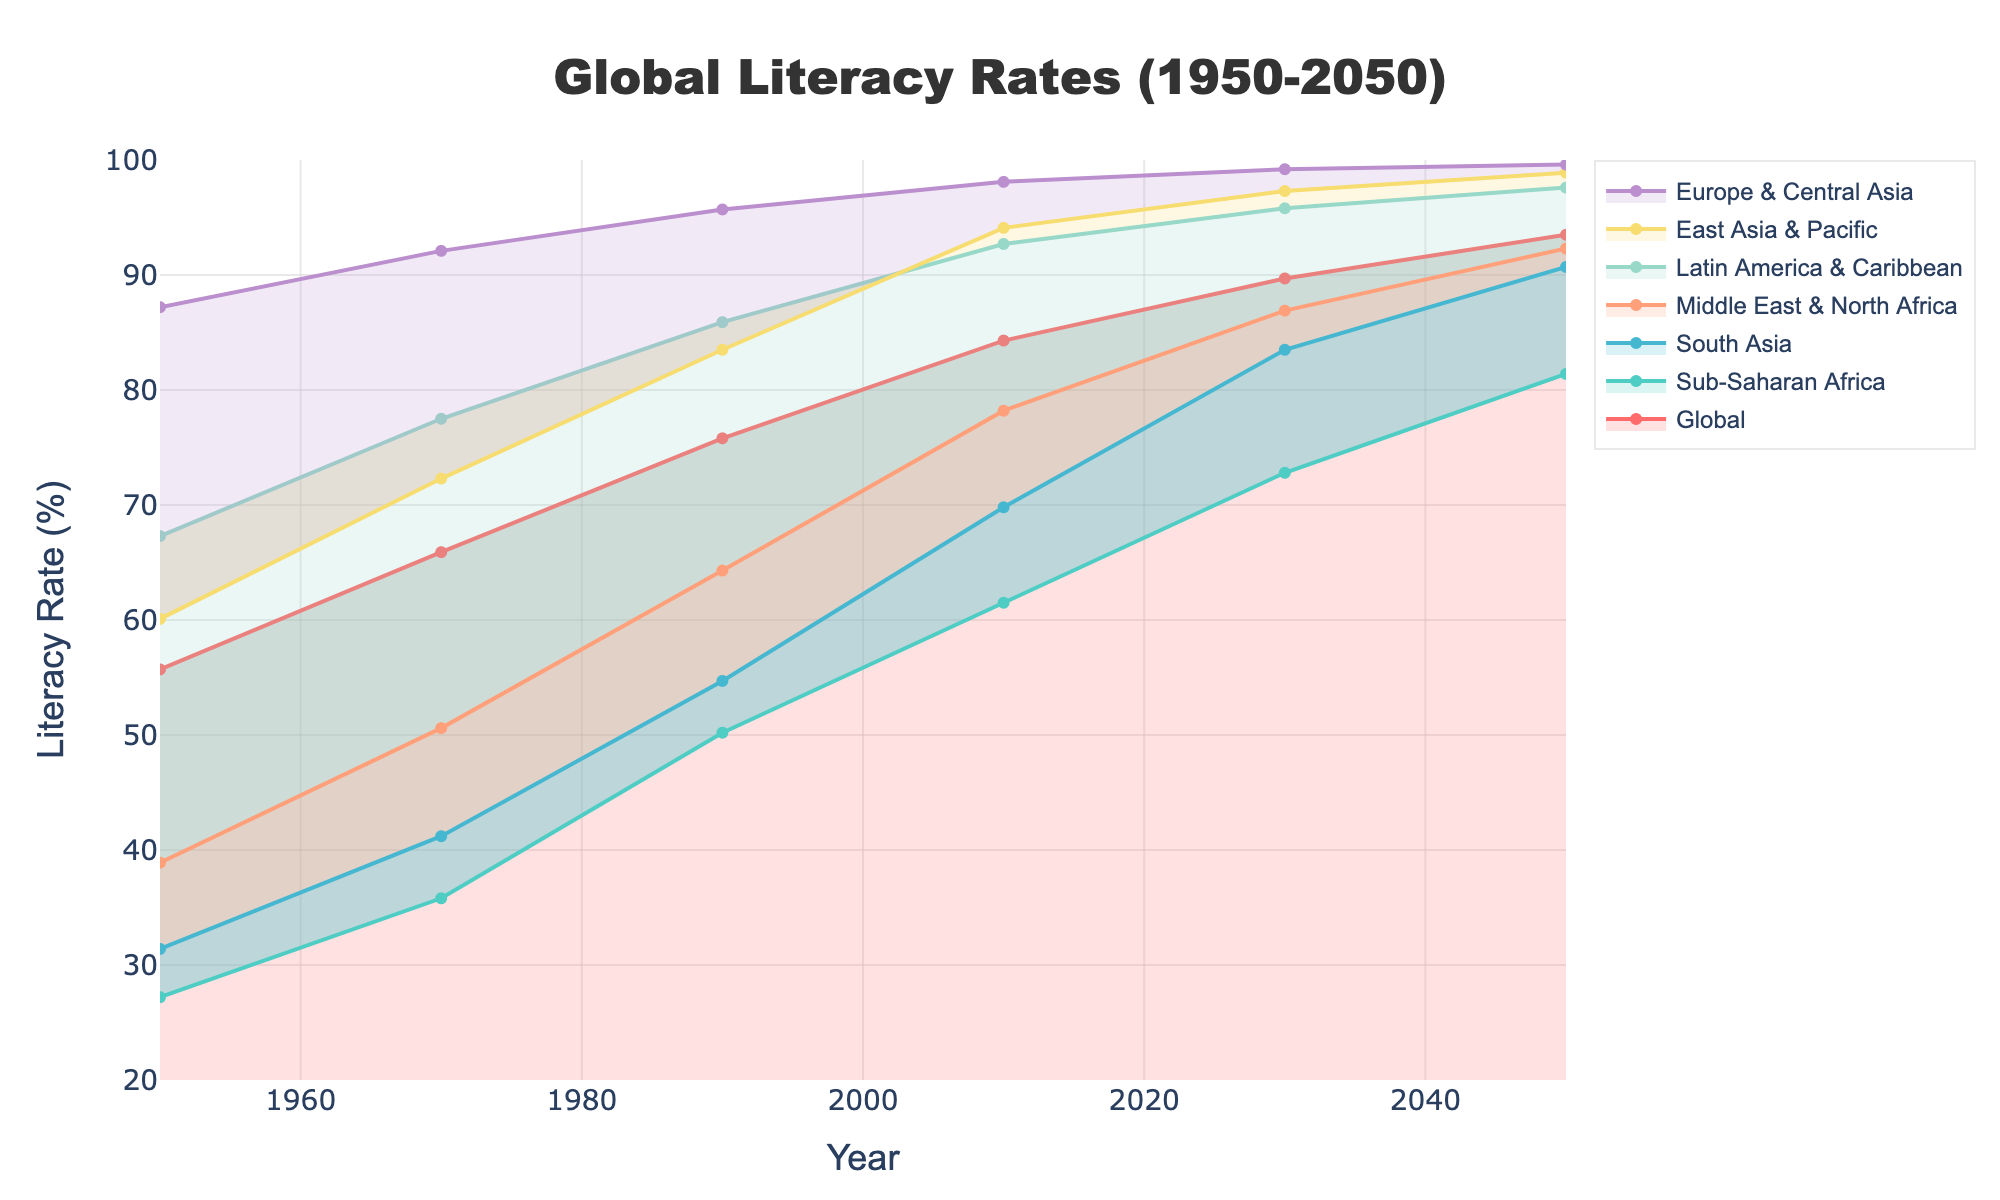What is the title of the figure? The title is prominently displayed at the top of the figure in a large and bold font. It reads "Global Literacy Rates (1950-2050)."
Answer: Global Literacy Rates (1950-2050) Which region had the lowest literacy rate in 1950? By looking at the leftmost side of the figure, we can see that Sub-Saharan Africa had the lowest literacy rate in 1950, indicated by the data point at the bottom of the respective area's color band.
Answer: Sub-Saharan Africa What is the literacy rate in East Asia & Pacific projected to be in 2050? Observing the projection for the year 2050, the figure shows the line or areas representing East Asia & Pacific, and the value at the end of the projection is approximately 98.9%.
Answer: 98.9% Which region is projected to have the highest increase in literacy rate from 1950 to 2050? We need to find the difference between the literacy rates in 1950 and 2050 for each region. Sub-Saharan Africa had a literacy rate of 27.2% in 1950 and is projected to have 81.4% in 2050. The increase is 81.4 - 27.2 = 54.2%. This is the largest increase among all regions.
Answer: Sub-Saharan Africa How has the global literacy rate changed from 1950 to 2010? The global literacy rate in 1950 was 55.7%, and in 2010 it was 84.3%. The change is calculated by 84.3 - 55.7 = 28.6%.
Answer: 28.6% Which two regions had the closest literacy rates in 1970? To answer this, we need to compare the literacy rates for all regions in 1970. Middle East & North Africa had 50.6%, and South Asia had 41.2%. The difference is small (approximately 9.4%), but the closest values are for East Asia & Pacific (72.3%) and Latin America & Caribbean (77.5%), with a difference of approximately 5.2%.
Answer: East Asia & Pacific and Latin America & Caribbean What is the literacy rate for Europe & Central Asia in 1990? The literacy rate for Europe & Central Asia in 1990 can be found by looking at the corresponding value in the figure. It is approximately 95.7%.
Answer: 95.7% Compare the literacy rates of Sub-Saharan Africa and South Asia in 2010. Which was higher? Observing the segments for Sub-Saharan Africa and South Asia in 2010, Sub-Saharan Africa had a literacy rate of 61.5%, while South Asia had 69.8%. South Asia's literacy rate was higher.
Answer: South Asia By how much is the global literacy rate expected to increase between 2010 and 2050? The global literacy rate in 2010 is 84.3%, while it is projected to be 93.5% in 2050. The expected increase is 93.5 - 84.3 = 9.2%.
Answer: 9.2% Which region is projected to achieve nearly universal literacy (98% or above) by 2050? Reviewing the projections for 2050, Europe & Central Asia (99.6%), East Asia & Pacific (98.9%), and Latin America & Caribbean (97.6%) reach near-universal literacy, with Europe & Central Asia clearly being above 98%.
Answer: Europe & Central Asia 